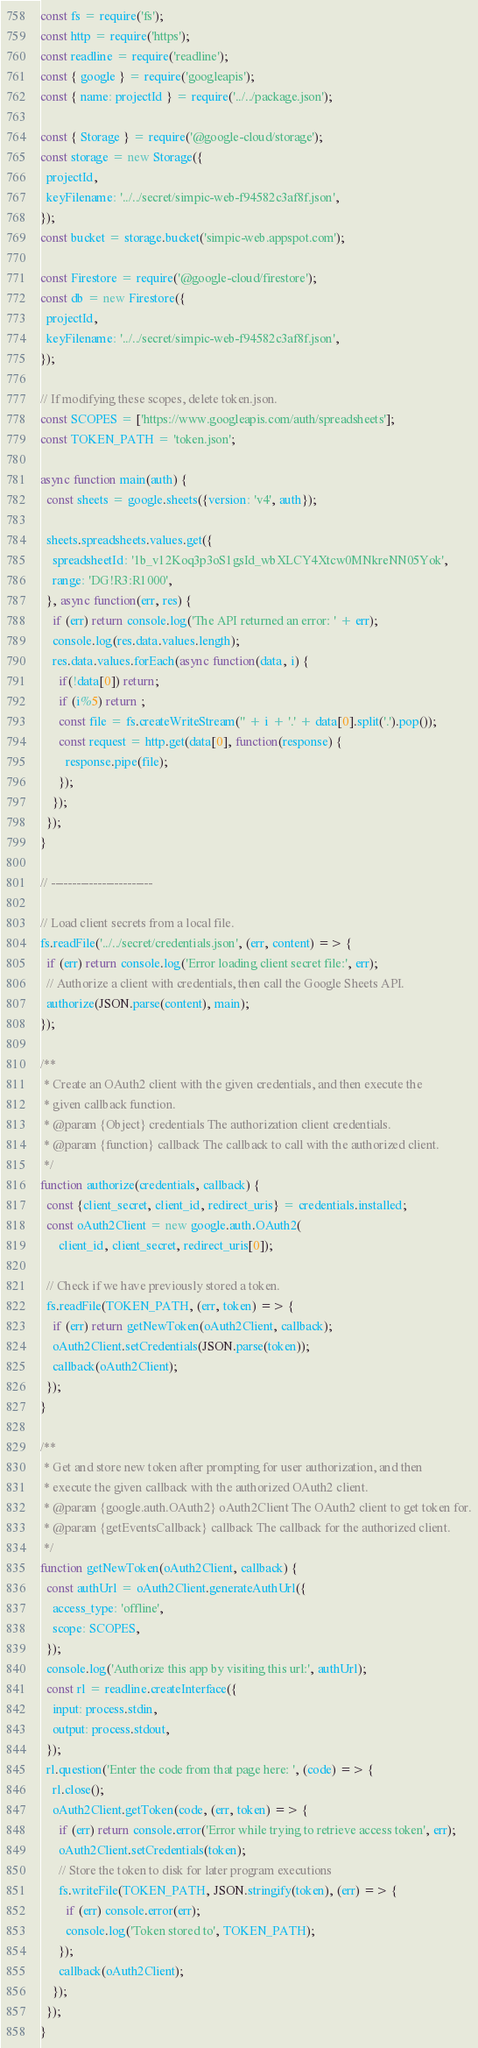<code> <loc_0><loc_0><loc_500><loc_500><_JavaScript_>const fs = require('fs');
const http = require('https');
const readline = require('readline');
const { google } = require('googleapis');
const { name: projectId } = require('../../package.json');

const { Storage } = require('@google-cloud/storage');
const storage = new Storage({
  projectId,
  keyFilename: '../../secret/simpic-web-f94582c3af8f.json',
});
const bucket = storage.bucket('simpic-web.appspot.com');

const Firestore = require('@google-cloud/firestore');
const db = new Firestore({
  projectId,
  keyFilename: '../../secret/simpic-web-f94582c3af8f.json',
});

// If modifying these scopes, delete token.json.
const SCOPES = ['https://www.googleapis.com/auth/spreadsheets'];
const TOKEN_PATH = 'token.json';

async function main(auth) {
  const sheets = google.sheets({version: 'v4', auth});

  sheets.spreadsheets.values.get({
    spreadsheetId: '1b_v12Koq3p3oS1gsId_wbXLCY4Xtcw0MNkreNN05Yok',
    range: 'DG!R3:R1000',
  }, async function(err, res) {
    if (err) return console.log('The API returned an error: ' + err);
    console.log(res.data.values.length);
    res.data.values.forEach(async function(data, i) {
      if(!data[0]) return;
      if (i%5) return ;
      const file = fs.createWriteStream('' + i + '.' + data[0].split('.').pop());
      const request = http.get(data[0], function(response) {
        response.pipe(file);
      });
    });
  });
}

// ------------------------

// Load client secrets from a local file.
fs.readFile('../../secret/credentials.json', (err, content) => {
  if (err) return console.log('Error loading client secret file:', err);
  // Authorize a client with credentials, then call the Google Sheets API.
  authorize(JSON.parse(content), main);
});

/**
 * Create an OAuth2 client with the given credentials, and then execute the
 * given callback function.
 * @param {Object} credentials The authorization client credentials.
 * @param {function} callback The callback to call with the authorized client.
 */
function authorize(credentials, callback) {
  const {client_secret, client_id, redirect_uris} = credentials.installed;
  const oAuth2Client = new google.auth.OAuth2(
      client_id, client_secret, redirect_uris[0]);

  // Check if we have previously stored a token.
  fs.readFile(TOKEN_PATH, (err, token) => {
    if (err) return getNewToken(oAuth2Client, callback);
    oAuth2Client.setCredentials(JSON.parse(token));
    callback(oAuth2Client);
  });
}

/**
 * Get and store new token after prompting for user authorization, and then
 * execute the given callback with the authorized OAuth2 client.
 * @param {google.auth.OAuth2} oAuth2Client The OAuth2 client to get token for.
 * @param {getEventsCallback} callback The callback for the authorized client.
 */
function getNewToken(oAuth2Client, callback) {
  const authUrl = oAuth2Client.generateAuthUrl({
    access_type: 'offline',
    scope: SCOPES,
  });
  console.log('Authorize this app by visiting this url:', authUrl);
  const rl = readline.createInterface({
    input: process.stdin,
    output: process.stdout,
  });
  rl.question('Enter the code from that page here: ', (code) => {
    rl.close();
    oAuth2Client.getToken(code, (err, token) => {
      if (err) return console.error('Error while trying to retrieve access token', err);
      oAuth2Client.setCredentials(token);
      // Store the token to disk for later program executions
      fs.writeFile(TOKEN_PATH, JSON.stringify(token), (err) => {
        if (err) console.error(err);
        console.log('Token stored to', TOKEN_PATH);
      });
      callback(oAuth2Client);
    });
  });
}</code> 